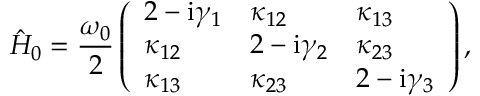Convert formula to latex. <formula><loc_0><loc_0><loc_500><loc_500>\hat { H } _ { 0 } = \frac { \omega _ { 0 } } { 2 } \left ( \begin{array} { l l l } { 2 - i \gamma _ { 1 } } & { \kappa _ { 1 2 } } & { \kappa _ { 1 3 } } \\ { \kappa _ { 1 2 } } & { 2 - i \gamma _ { 2 } } & { \kappa _ { 2 3 } } \\ { \kappa _ { 1 3 } } & { \kappa _ { 2 3 } } & { 2 - i \gamma _ { 3 } } \end{array} \right ) ,</formula> 